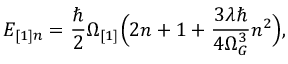<formula> <loc_0><loc_0><loc_500><loc_500>E _ { [ 1 ] n } = \frac { } { 2 } \Omega _ { [ 1 ] } \left ( 2 n + 1 + \frac { 3 \lambda } { 4 \Omega _ { G } ^ { 3 } } n ^ { 2 } \right ) ,</formula> 